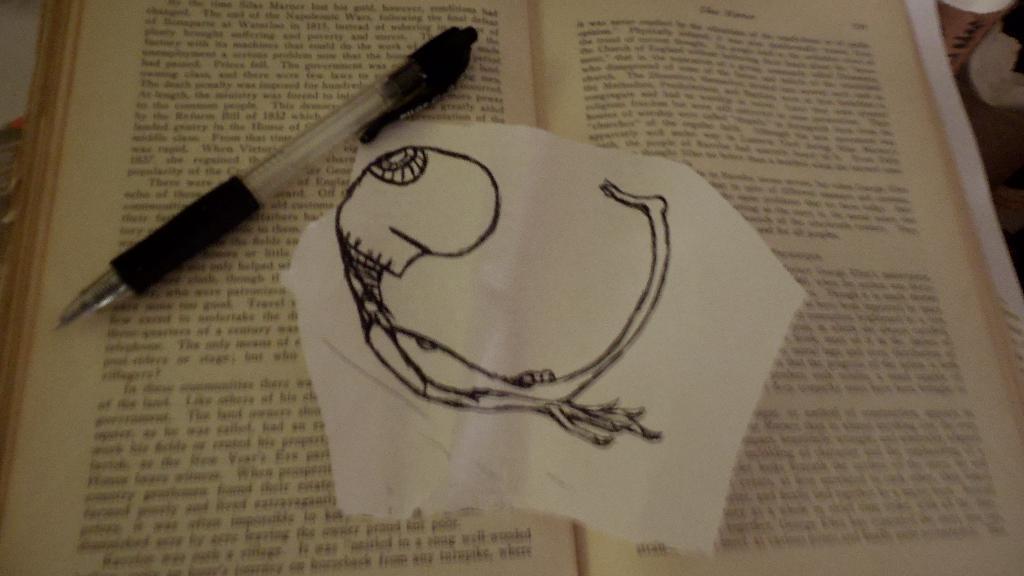Please provide a concise description of this image. In this picture we can see a pen and a paper on the book. 